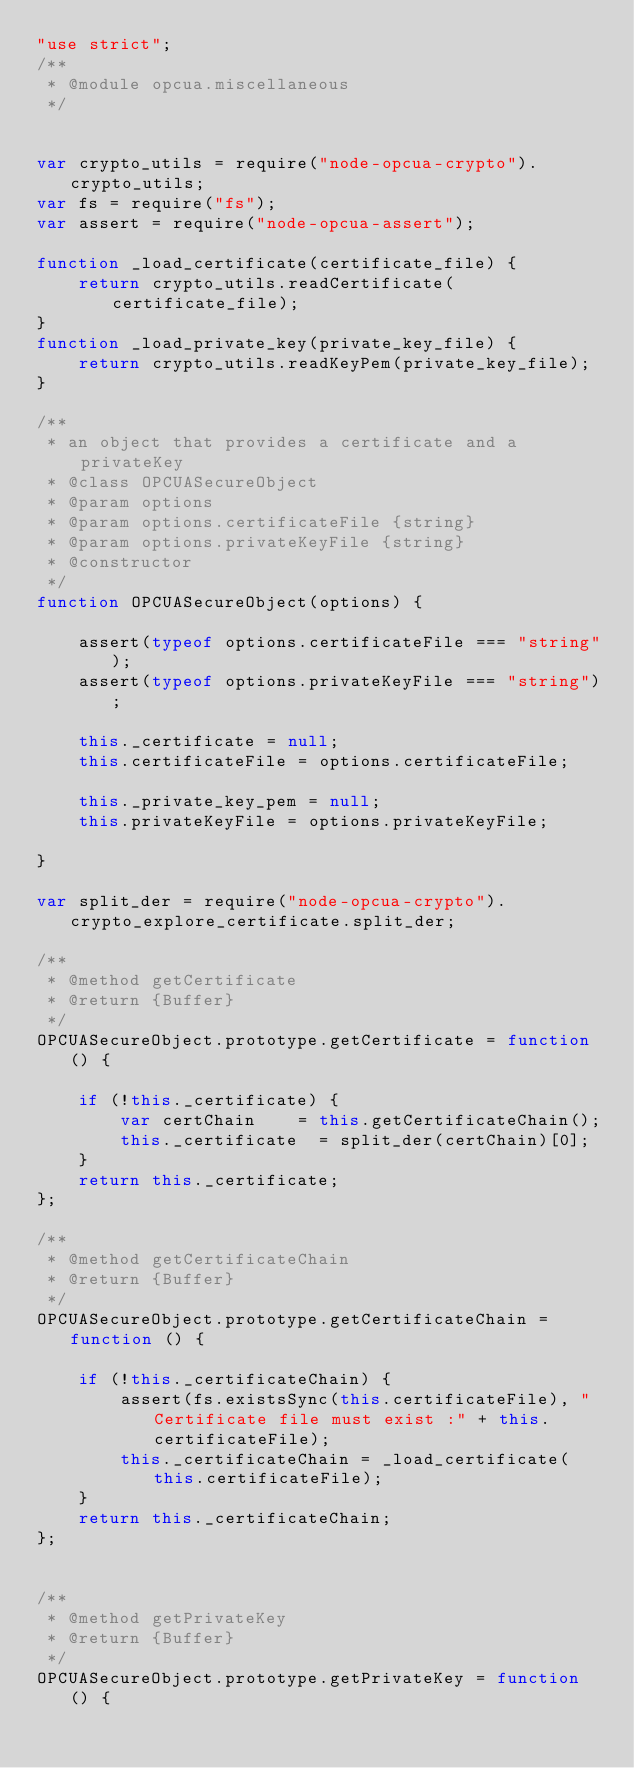Convert code to text. <code><loc_0><loc_0><loc_500><loc_500><_JavaScript_>"use strict";
/**
 * @module opcua.miscellaneous
 */


var crypto_utils = require("node-opcua-crypto").crypto_utils;
var fs = require("fs");
var assert = require("node-opcua-assert");

function _load_certificate(certificate_file) {
    return crypto_utils.readCertificate(certificate_file);
}
function _load_private_key(private_key_file) {
    return crypto_utils.readKeyPem(private_key_file);
}

/**
 * an object that provides a certificate and a privateKey
 * @class OPCUASecureObject
 * @param options
 * @param options.certificateFile {string}
 * @param options.privateKeyFile {string}
 * @constructor
 */
function OPCUASecureObject(options) {

    assert(typeof options.certificateFile === "string");
    assert(typeof options.privateKeyFile === "string");

    this._certificate = null;
    this.certificateFile = options.certificateFile;

    this._private_key_pem = null;
    this.privateKeyFile = options.privateKeyFile;

}

var split_der = require("node-opcua-crypto").crypto_explore_certificate.split_der;

/**
 * @method getCertificate
 * @return {Buffer}
 */
OPCUASecureObject.prototype.getCertificate = function () {

    if (!this._certificate) {
        var certChain    = this.getCertificateChain();
        this._certificate  = split_der(certChain)[0];
    }
    return this._certificate;
};

/**
 * @method getCertificateChain
 * @return {Buffer}
 */
OPCUASecureObject.prototype.getCertificateChain = function () {

    if (!this._certificateChain) {
        assert(fs.existsSync(this.certificateFile), "Certificate file must exist :" + this.certificateFile);
        this._certificateChain = _load_certificate(this.certificateFile);
    }
    return this._certificateChain;
};


/**
 * @method getPrivateKey
 * @return {Buffer}
 */
OPCUASecureObject.prototype.getPrivateKey = function () {
</code> 